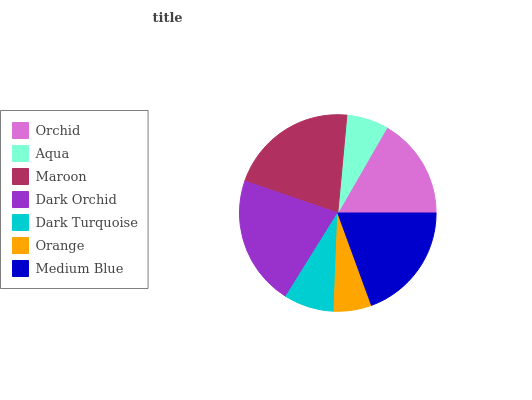Is Orange the minimum?
Answer yes or no. Yes. Is Dark Orchid the maximum?
Answer yes or no. Yes. Is Aqua the minimum?
Answer yes or no. No. Is Aqua the maximum?
Answer yes or no. No. Is Orchid greater than Aqua?
Answer yes or no. Yes. Is Aqua less than Orchid?
Answer yes or no. Yes. Is Aqua greater than Orchid?
Answer yes or no. No. Is Orchid less than Aqua?
Answer yes or no. No. Is Orchid the high median?
Answer yes or no. Yes. Is Orchid the low median?
Answer yes or no. Yes. Is Dark Orchid the high median?
Answer yes or no. No. Is Medium Blue the low median?
Answer yes or no. No. 